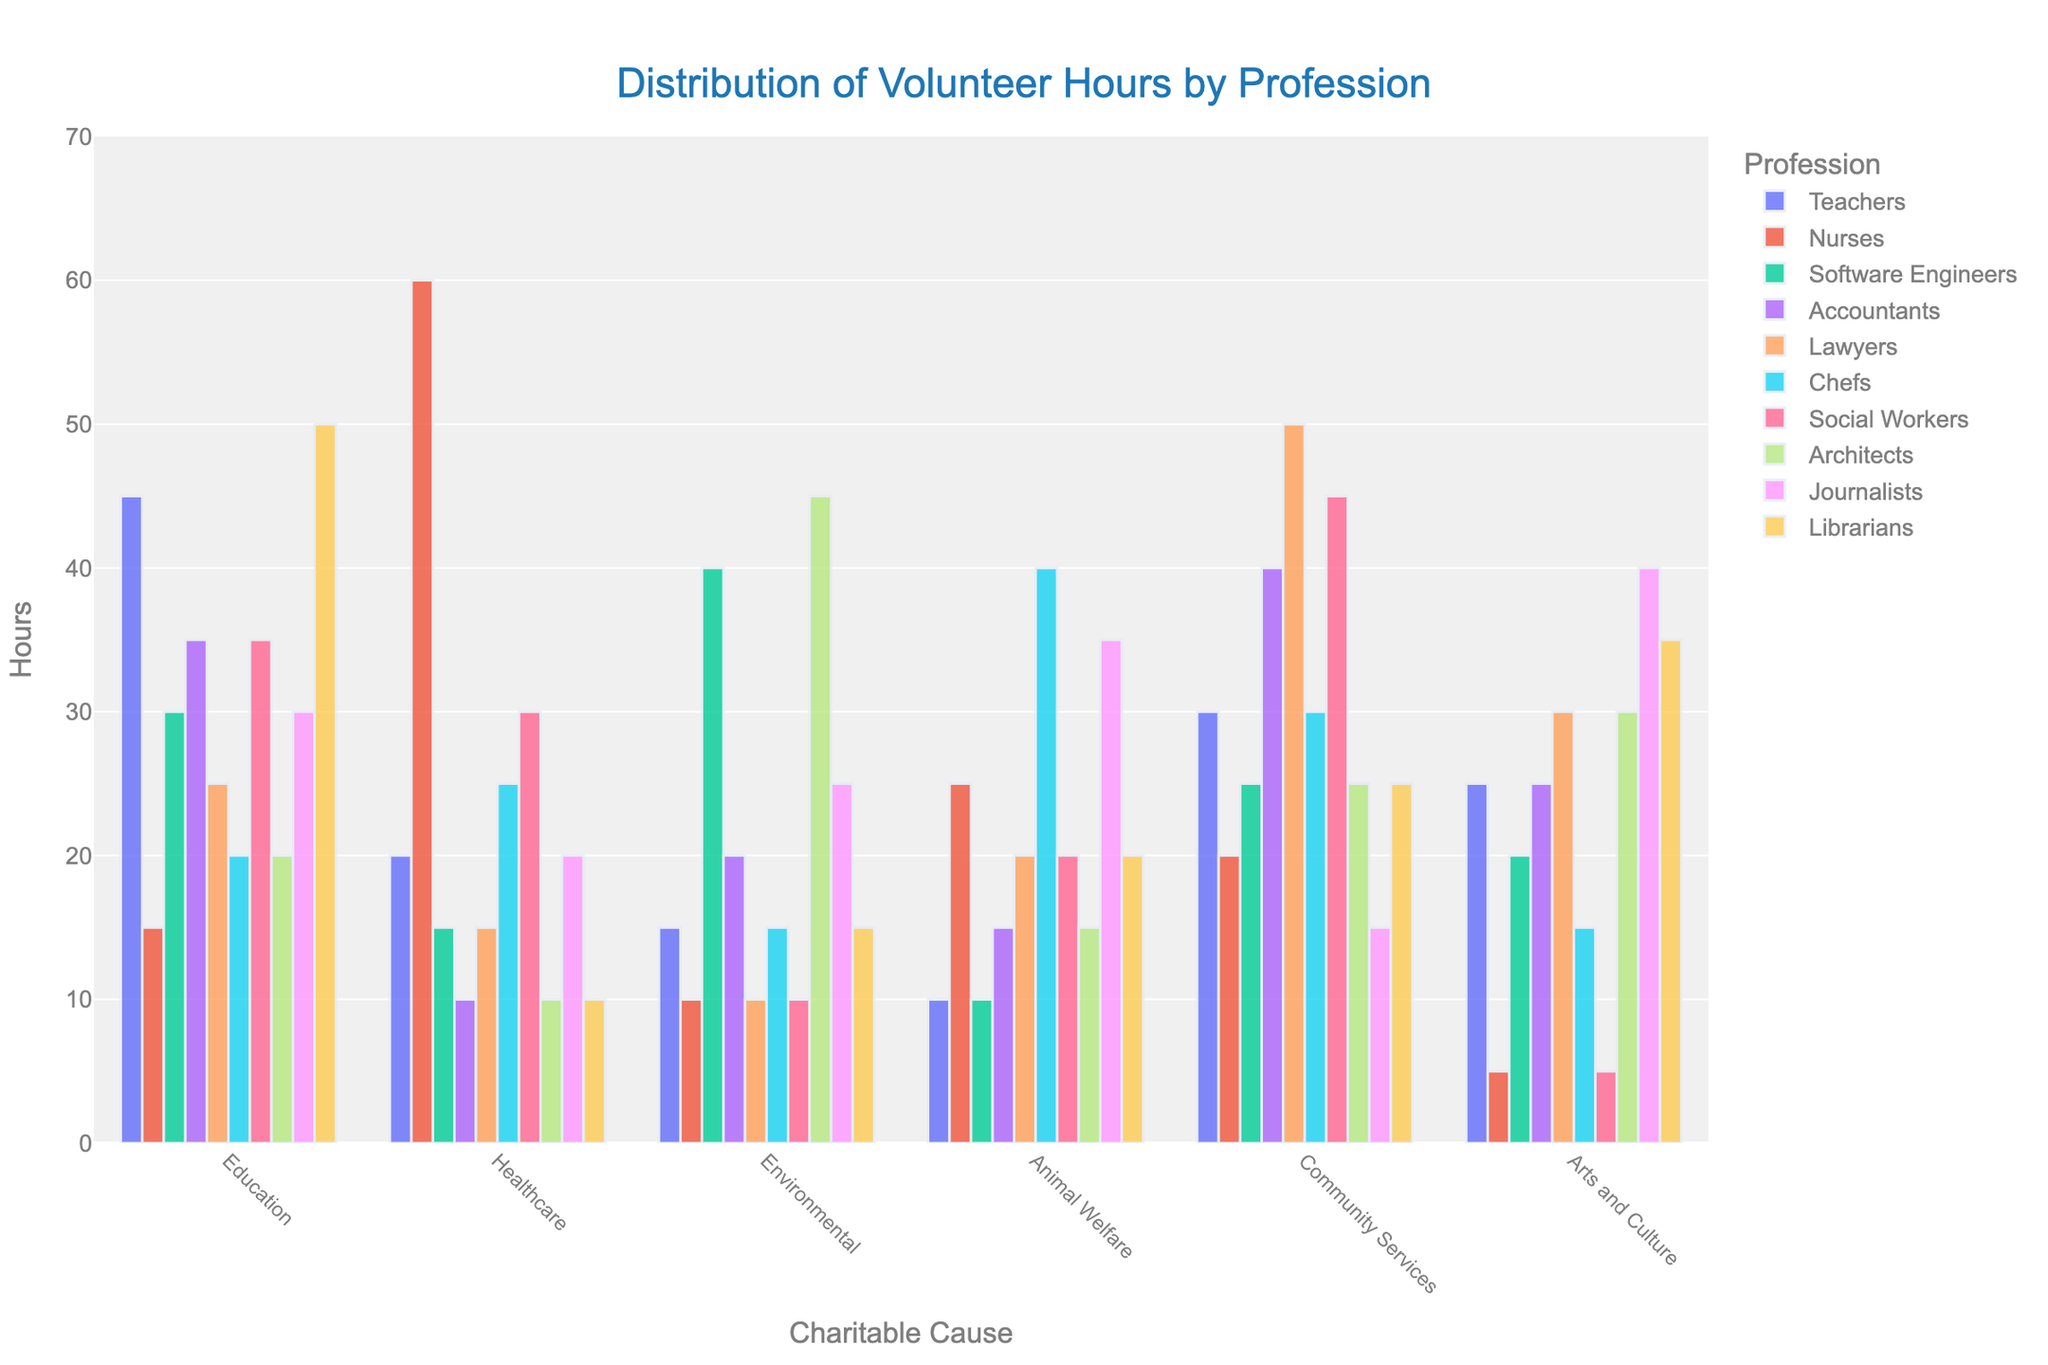what's the profession with the highest volunteer hours in Education? The bar representing 'Librarians' in the 'Education' category is the tallest.
Answer: Librarians Which profession contributed the least hours to Healthcare? The bar for 'Accountants' in the 'Healthcare' category is the shortest.
Answer: Accountants Which charitable cause received the most hours from 'Chefs'? The bar representing 'Animal Welfare' is the tallest for the 'Chefs' profession.
Answer: Animal Welfare What's the total number of volunteer hours contributed by 'Journalists'? Sum the hours for 'Journalists' across all causes: 30 (Education) + 20 (Healthcare) + 25 (Environmental) + 35 (Animal Welfare) + 15 (Community Services) + 40 (Arts and Culture) = 165
Answer: 165 Compare the volunteer hours between 'Lawyers' and 'Teachers' in 'Community Services'. Who contributed more and by how much? Teachers contributed 30 hours and Lawyers contributed 50 hours in 'Community Services', so Lawyers contributed 20 more hours.
Answer: Lawyers, 20 more hours Which profession has the most evenly distributed volunteer hours across all causes? By visually inspecting the heights of the bars for each profession, 'Social Workers' show relatively even distribution across all causes.
Answer: Social Workers What is the difference in volunteer hours between 'Software Engineers' and 'Architects' in 'Environmental'? Software Engineers contributed 40 hours and Architects contributed 45 hours in 'Environmental'. The difference is 45 - 40 = 5 hours.
Answer: 5 hours What is the average number of hours contributed by 'Teachers' across all causes? Sum the hours for Teachers: 45 + 20 + 15 + 10 + 30 + 25 = 145. Divide by the number of causes (6): 145/6 ≈ 24.17
Answer: 24.17 Which profession spent the least time in the 'Arts and Culture' cause and what is the number of hours? Look for the shortest bar in 'Arts and Culture'; Nurses spent the least time with 5 hours.
Answer: Nurses, 5 What's the sum of volunteer hours provided by 'Accountants' in the 'Community Services' and 'Arts and Culture' causes? Accountants contributed 40 hours in 'Community Services' and 25 hours in 'Arts and Culture'. The total is 40+25 = 65.
Answer: 65 